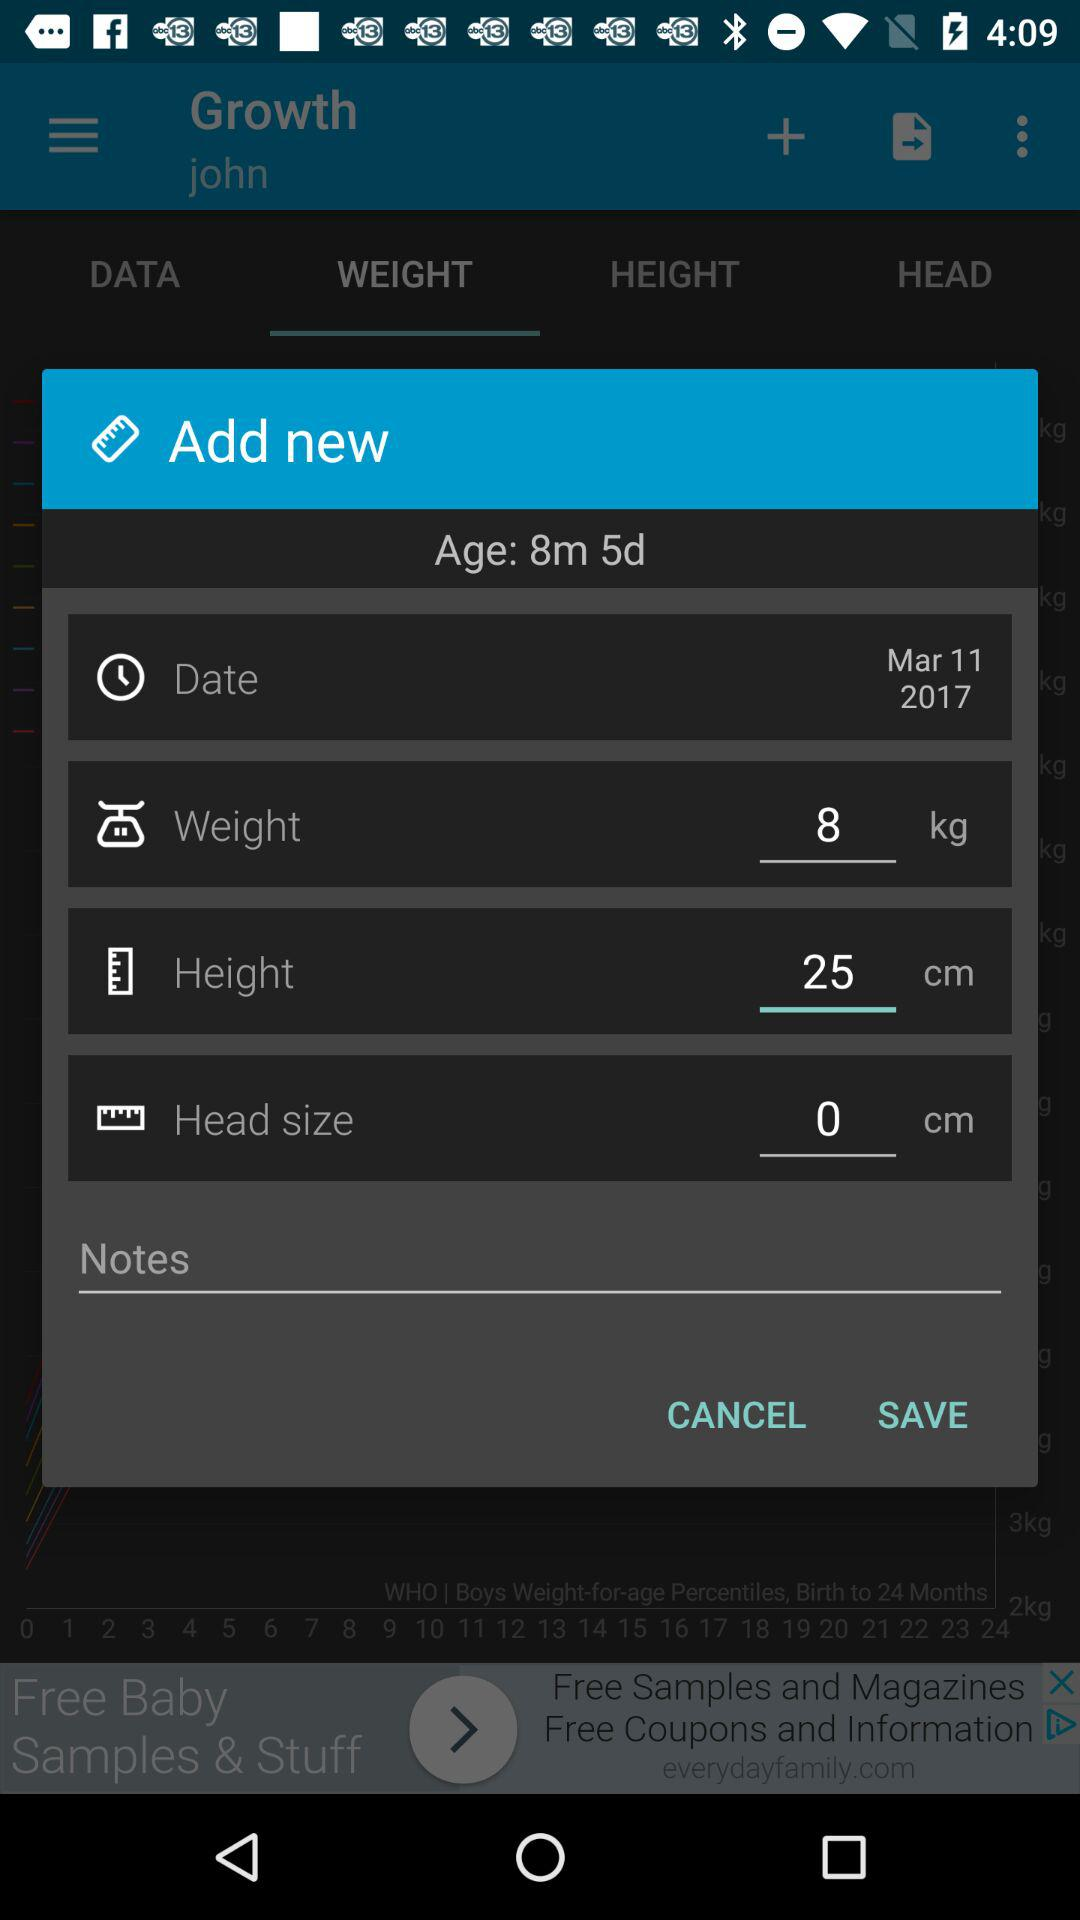What is the age given on the screenshot? The given age is 8 months and 5 days. 